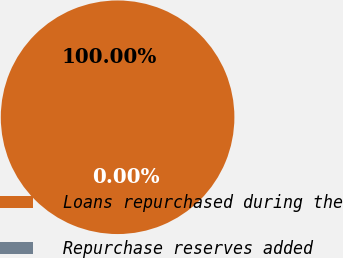<chart> <loc_0><loc_0><loc_500><loc_500><pie_chart><fcel>Loans repurchased during the<fcel>Repurchase reserves added<nl><fcel>100.0%<fcel>0.0%<nl></chart> 